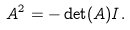Convert formula to latex. <formula><loc_0><loc_0><loc_500><loc_500>A ^ { 2 } = - \det ( A ) I .</formula> 